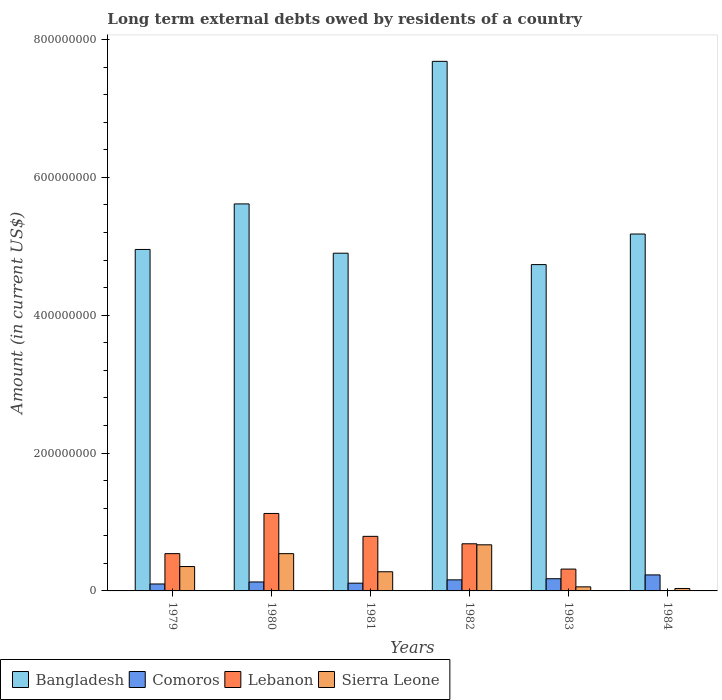How many groups of bars are there?
Offer a very short reply. 6. Are the number of bars per tick equal to the number of legend labels?
Provide a short and direct response. No. Are the number of bars on each tick of the X-axis equal?
Your response must be concise. No. In how many cases, is the number of bars for a given year not equal to the number of legend labels?
Offer a very short reply. 1. What is the amount of long-term external debts owed by residents in Bangladesh in 1980?
Offer a terse response. 5.61e+08. Across all years, what is the maximum amount of long-term external debts owed by residents in Sierra Leone?
Offer a very short reply. 6.69e+07. Across all years, what is the minimum amount of long-term external debts owed by residents in Bangladesh?
Your response must be concise. 4.73e+08. What is the total amount of long-term external debts owed by residents in Lebanon in the graph?
Keep it short and to the point. 3.46e+08. What is the difference between the amount of long-term external debts owed by residents in Lebanon in 1979 and that in 1981?
Your response must be concise. -2.51e+07. What is the difference between the amount of long-term external debts owed by residents in Sierra Leone in 1983 and the amount of long-term external debts owed by residents in Lebanon in 1980?
Provide a short and direct response. -1.06e+08. What is the average amount of long-term external debts owed by residents in Bangladesh per year?
Your answer should be compact. 5.51e+08. In the year 1983, what is the difference between the amount of long-term external debts owed by residents in Sierra Leone and amount of long-term external debts owed by residents in Comoros?
Provide a succinct answer. -1.18e+07. In how many years, is the amount of long-term external debts owed by residents in Comoros greater than 360000000 US$?
Offer a terse response. 0. What is the ratio of the amount of long-term external debts owed by residents in Comoros in 1979 to that in 1983?
Your answer should be very brief. 0.57. Is the amount of long-term external debts owed by residents in Sierra Leone in 1981 less than that in 1983?
Give a very brief answer. No. Is the difference between the amount of long-term external debts owed by residents in Sierra Leone in 1979 and 1984 greater than the difference between the amount of long-term external debts owed by residents in Comoros in 1979 and 1984?
Offer a very short reply. Yes. What is the difference between the highest and the second highest amount of long-term external debts owed by residents in Sierra Leone?
Your answer should be very brief. 1.28e+07. What is the difference between the highest and the lowest amount of long-term external debts owed by residents in Sierra Leone?
Provide a short and direct response. 6.33e+07. Is the sum of the amount of long-term external debts owed by residents in Comoros in 1979 and 1983 greater than the maximum amount of long-term external debts owed by residents in Sierra Leone across all years?
Provide a short and direct response. No. Is it the case that in every year, the sum of the amount of long-term external debts owed by residents in Bangladesh and amount of long-term external debts owed by residents in Sierra Leone is greater than the amount of long-term external debts owed by residents in Comoros?
Offer a terse response. Yes. Are all the bars in the graph horizontal?
Ensure brevity in your answer.  No. What is the difference between two consecutive major ticks on the Y-axis?
Provide a succinct answer. 2.00e+08. Does the graph contain any zero values?
Your answer should be compact. Yes. How many legend labels are there?
Make the answer very short. 4. How are the legend labels stacked?
Ensure brevity in your answer.  Horizontal. What is the title of the graph?
Keep it short and to the point. Long term external debts owed by residents of a country. What is the label or title of the Y-axis?
Make the answer very short. Amount (in current US$). What is the Amount (in current US$) in Bangladesh in 1979?
Your answer should be compact. 4.95e+08. What is the Amount (in current US$) of Comoros in 1979?
Provide a short and direct response. 1.01e+07. What is the Amount (in current US$) in Lebanon in 1979?
Your response must be concise. 5.41e+07. What is the Amount (in current US$) in Sierra Leone in 1979?
Offer a terse response. 3.54e+07. What is the Amount (in current US$) in Bangladesh in 1980?
Keep it short and to the point. 5.61e+08. What is the Amount (in current US$) of Comoros in 1980?
Your answer should be compact. 1.30e+07. What is the Amount (in current US$) in Lebanon in 1980?
Offer a terse response. 1.12e+08. What is the Amount (in current US$) of Sierra Leone in 1980?
Your response must be concise. 5.41e+07. What is the Amount (in current US$) of Bangladesh in 1981?
Keep it short and to the point. 4.90e+08. What is the Amount (in current US$) in Comoros in 1981?
Your answer should be compact. 1.13e+07. What is the Amount (in current US$) of Lebanon in 1981?
Your answer should be very brief. 7.92e+07. What is the Amount (in current US$) in Sierra Leone in 1981?
Your answer should be very brief. 2.78e+07. What is the Amount (in current US$) in Bangladesh in 1982?
Give a very brief answer. 7.68e+08. What is the Amount (in current US$) of Comoros in 1982?
Provide a short and direct response. 1.61e+07. What is the Amount (in current US$) of Lebanon in 1982?
Provide a succinct answer. 6.84e+07. What is the Amount (in current US$) in Sierra Leone in 1982?
Ensure brevity in your answer.  6.69e+07. What is the Amount (in current US$) in Bangladesh in 1983?
Keep it short and to the point. 4.73e+08. What is the Amount (in current US$) in Comoros in 1983?
Your answer should be very brief. 1.77e+07. What is the Amount (in current US$) in Lebanon in 1983?
Provide a succinct answer. 3.17e+07. What is the Amount (in current US$) of Sierra Leone in 1983?
Your answer should be very brief. 5.91e+06. What is the Amount (in current US$) in Bangladesh in 1984?
Keep it short and to the point. 5.18e+08. What is the Amount (in current US$) in Comoros in 1984?
Keep it short and to the point. 2.32e+07. What is the Amount (in current US$) in Lebanon in 1984?
Make the answer very short. 0. What is the Amount (in current US$) in Sierra Leone in 1984?
Your response must be concise. 3.56e+06. Across all years, what is the maximum Amount (in current US$) in Bangladesh?
Provide a short and direct response. 7.68e+08. Across all years, what is the maximum Amount (in current US$) in Comoros?
Give a very brief answer. 2.32e+07. Across all years, what is the maximum Amount (in current US$) in Lebanon?
Provide a short and direct response. 1.12e+08. Across all years, what is the maximum Amount (in current US$) of Sierra Leone?
Give a very brief answer. 6.69e+07. Across all years, what is the minimum Amount (in current US$) of Bangladesh?
Ensure brevity in your answer.  4.73e+08. Across all years, what is the minimum Amount (in current US$) of Comoros?
Keep it short and to the point. 1.01e+07. Across all years, what is the minimum Amount (in current US$) of Sierra Leone?
Offer a terse response. 3.56e+06. What is the total Amount (in current US$) in Bangladesh in the graph?
Your answer should be very brief. 3.31e+09. What is the total Amount (in current US$) in Comoros in the graph?
Your response must be concise. 9.13e+07. What is the total Amount (in current US$) in Lebanon in the graph?
Ensure brevity in your answer.  3.46e+08. What is the total Amount (in current US$) of Sierra Leone in the graph?
Your response must be concise. 1.94e+08. What is the difference between the Amount (in current US$) in Bangladesh in 1979 and that in 1980?
Ensure brevity in your answer.  -6.61e+07. What is the difference between the Amount (in current US$) of Comoros in 1979 and that in 1980?
Your answer should be very brief. -2.92e+06. What is the difference between the Amount (in current US$) of Lebanon in 1979 and that in 1980?
Your response must be concise. -5.83e+07. What is the difference between the Amount (in current US$) in Sierra Leone in 1979 and that in 1980?
Ensure brevity in your answer.  -1.87e+07. What is the difference between the Amount (in current US$) in Bangladesh in 1979 and that in 1981?
Offer a very short reply. 5.44e+06. What is the difference between the Amount (in current US$) of Comoros in 1979 and that in 1981?
Provide a short and direct response. -1.18e+06. What is the difference between the Amount (in current US$) of Lebanon in 1979 and that in 1981?
Your response must be concise. -2.51e+07. What is the difference between the Amount (in current US$) in Sierra Leone in 1979 and that in 1981?
Offer a terse response. 7.58e+06. What is the difference between the Amount (in current US$) of Bangladesh in 1979 and that in 1982?
Provide a short and direct response. -2.73e+08. What is the difference between the Amount (in current US$) of Comoros in 1979 and that in 1982?
Ensure brevity in your answer.  -5.98e+06. What is the difference between the Amount (in current US$) in Lebanon in 1979 and that in 1982?
Provide a succinct answer. -1.43e+07. What is the difference between the Amount (in current US$) in Sierra Leone in 1979 and that in 1982?
Give a very brief answer. -3.15e+07. What is the difference between the Amount (in current US$) in Bangladesh in 1979 and that in 1983?
Keep it short and to the point. 2.20e+07. What is the difference between the Amount (in current US$) of Comoros in 1979 and that in 1983?
Your response must be concise. -7.62e+06. What is the difference between the Amount (in current US$) of Lebanon in 1979 and that in 1983?
Make the answer very short. 2.24e+07. What is the difference between the Amount (in current US$) in Sierra Leone in 1979 and that in 1983?
Your answer should be very brief. 2.95e+07. What is the difference between the Amount (in current US$) of Bangladesh in 1979 and that in 1984?
Keep it short and to the point. -2.24e+07. What is the difference between the Amount (in current US$) of Comoros in 1979 and that in 1984?
Provide a short and direct response. -1.31e+07. What is the difference between the Amount (in current US$) in Sierra Leone in 1979 and that in 1984?
Your answer should be very brief. 3.18e+07. What is the difference between the Amount (in current US$) in Bangladesh in 1980 and that in 1981?
Keep it short and to the point. 7.15e+07. What is the difference between the Amount (in current US$) of Comoros in 1980 and that in 1981?
Provide a succinct answer. 1.74e+06. What is the difference between the Amount (in current US$) in Lebanon in 1980 and that in 1981?
Provide a succinct answer. 3.32e+07. What is the difference between the Amount (in current US$) in Sierra Leone in 1980 and that in 1981?
Provide a succinct answer. 2.63e+07. What is the difference between the Amount (in current US$) of Bangladesh in 1980 and that in 1982?
Give a very brief answer. -2.07e+08. What is the difference between the Amount (in current US$) in Comoros in 1980 and that in 1982?
Make the answer very short. -3.06e+06. What is the difference between the Amount (in current US$) of Lebanon in 1980 and that in 1982?
Provide a short and direct response. 4.40e+07. What is the difference between the Amount (in current US$) in Sierra Leone in 1980 and that in 1982?
Provide a succinct answer. -1.28e+07. What is the difference between the Amount (in current US$) of Bangladesh in 1980 and that in 1983?
Provide a short and direct response. 8.80e+07. What is the difference between the Amount (in current US$) in Comoros in 1980 and that in 1983?
Ensure brevity in your answer.  -4.70e+06. What is the difference between the Amount (in current US$) of Lebanon in 1980 and that in 1983?
Your answer should be compact. 8.07e+07. What is the difference between the Amount (in current US$) of Sierra Leone in 1980 and that in 1983?
Ensure brevity in your answer.  4.82e+07. What is the difference between the Amount (in current US$) of Bangladesh in 1980 and that in 1984?
Give a very brief answer. 4.37e+07. What is the difference between the Amount (in current US$) of Comoros in 1980 and that in 1984?
Your answer should be very brief. -1.02e+07. What is the difference between the Amount (in current US$) of Sierra Leone in 1980 and that in 1984?
Your answer should be very brief. 5.05e+07. What is the difference between the Amount (in current US$) of Bangladesh in 1981 and that in 1982?
Offer a very short reply. -2.78e+08. What is the difference between the Amount (in current US$) in Comoros in 1981 and that in 1982?
Keep it short and to the point. -4.79e+06. What is the difference between the Amount (in current US$) of Lebanon in 1981 and that in 1982?
Make the answer very short. 1.08e+07. What is the difference between the Amount (in current US$) in Sierra Leone in 1981 and that in 1982?
Provide a succinct answer. -3.91e+07. What is the difference between the Amount (in current US$) in Bangladesh in 1981 and that in 1983?
Offer a terse response. 1.65e+07. What is the difference between the Amount (in current US$) of Comoros in 1981 and that in 1983?
Offer a very short reply. -6.43e+06. What is the difference between the Amount (in current US$) of Lebanon in 1981 and that in 1983?
Offer a very short reply. 4.75e+07. What is the difference between the Amount (in current US$) in Sierra Leone in 1981 and that in 1983?
Keep it short and to the point. 2.19e+07. What is the difference between the Amount (in current US$) in Bangladesh in 1981 and that in 1984?
Your answer should be very brief. -2.78e+07. What is the difference between the Amount (in current US$) in Comoros in 1981 and that in 1984?
Offer a very short reply. -1.20e+07. What is the difference between the Amount (in current US$) of Sierra Leone in 1981 and that in 1984?
Provide a short and direct response. 2.42e+07. What is the difference between the Amount (in current US$) of Bangladesh in 1982 and that in 1983?
Your response must be concise. 2.95e+08. What is the difference between the Amount (in current US$) of Comoros in 1982 and that in 1983?
Your answer should be very brief. -1.64e+06. What is the difference between the Amount (in current US$) of Lebanon in 1982 and that in 1983?
Make the answer very short. 3.67e+07. What is the difference between the Amount (in current US$) of Sierra Leone in 1982 and that in 1983?
Offer a very short reply. 6.10e+07. What is the difference between the Amount (in current US$) of Bangladesh in 1982 and that in 1984?
Provide a short and direct response. 2.50e+08. What is the difference between the Amount (in current US$) in Comoros in 1982 and that in 1984?
Provide a short and direct response. -7.17e+06. What is the difference between the Amount (in current US$) in Sierra Leone in 1982 and that in 1984?
Give a very brief answer. 6.33e+07. What is the difference between the Amount (in current US$) of Bangladesh in 1983 and that in 1984?
Your answer should be very brief. -4.43e+07. What is the difference between the Amount (in current US$) of Comoros in 1983 and that in 1984?
Provide a short and direct response. -5.53e+06. What is the difference between the Amount (in current US$) of Sierra Leone in 1983 and that in 1984?
Offer a very short reply. 2.35e+06. What is the difference between the Amount (in current US$) of Bangladesh in 1979 and the Amount (in current US$) of Comoros in 1980?
Provide a succinct answer. 4.82e+08. What is the difference between the Amount (in current US$) of Bangladesh in 1979 and the Amount (in current US$) of Lebanon in 1980?
Offer a terse response. 3.83e+08. What is the difference between the Amount (in current US$) of Bangladesh in 1979 and the Amount (in current US$) of Sierra Leone in 1980?
Make the answer very short. 4.41e+08. What is the difference between the Amount (in current US$) in Comoros in 1979 and the Amount (in current US$) in Lebanon in 1980?
Give a very brief answer. -1.02e+08. What is the difference between the Amount (in current US$) in Comoros in 1979 and the Amount (in current US$) in Sierra Leone in 1980?
Provide a succinct answer. -4.40e+07. What is the difference between the Amount (in current US$) in Lebanon in 1979 and the Amount (in current US$) in Sierra Leone in 1980?
Ensure brevity in your answer.  2.30e+04. What is the difference between the Amount (in current US$) of Bangladesh in 1979 and the Amount (in current US$) of Comoros in 1981?
Ensure brevity in your answer.  4.84e+08. What is the difference between the Amount (in current US$) of Bangladesh in 1979 and the Amount (in current US$) of Lebanon in 1981?
Offer a very short reply. 4.16e+08. What is the difference between the Amount (in current US$) in Bangladesh in 1979 and the Amount (in current US$) in Sierra Leone in 1981?
Give a very brief answer. 4.68e+08. What is the difference between the Amount (in current US$) in Comoros in 1979 and the Amount (in current US$) in Lebanon in 1981?
Your answer should be very brief. -6.91e+07. What is the difference between the Amount (in current US$) of Comoros in 1979 and the Amount (in current US$) of Sierra Leone in 1981?
Ensure brevity in your answer.  -1.77e+07. What is the difference between the Amount (in current US$) in Lebanon in 1979 and the Amount (in current US$) in Sierra Leone in 1981?
Ensure brevity in your answer.  2.63e+07. What is the difference between the Amount (in current US$) of Bangladesh in 1979 and the Amount (in current US$) of Comoros in 1982?
Ensure brevity in your answer.  4.79e+08. What is the difference between the Amount (in current US$) in Bangladesh in 1979 and the Amount (in current US$) in Lebanon in 1982?
Make the answer very short. 4.27e+08. What is the difference between the Amount (in current US$) of Bangladesh in 1979 and the Amount (in current US$) of Sierra Leone in 1982?
Offer a very short reply. 4.28e+08. What is the difference between the Amount (in current US$) in Comoros in 1979 and the Amount (in current US$) in Lebanon in 1982?
Provide a short and direct response. -5.83e+07. What is the difference between the Amount (in current US$) in Comoros in 1979 and the Amount (in current US$) in Sierra Leone in 1982?
Your answer should be very brief. -5.68e+07. What is the difference between the Amount (in current US$) of Lebanon in 1979 and the Amount (in current US$) of Sierra Leone in 1982?
Provide a short and direct response. -1.28e+07. What is the difference between the Amount (in current US$) of Bangladesh in 1979 and the Amount (in current US$) of Comoros in 1983?
Your answer should be compact. 4.78e+08. What is the difference between the Amount (in current US$) of Bangladesh in 1979 and the Amount (in current US$) of Lebanon in 1983?
Offer a terse response. 4.64e+08. What is the difference between the Amount (in current US$) of Bangladesh in 1979 and the Amount (in current US$) of Sierra Leone in 1983?
Offer a very short reply. 4.89e+08. What is the difference between the Amount (in current US$) in Comoros in 1979 and the Amount (in current US$) in Lebanon in 1983?
Offer a very short reply. -2.16e+07. What is the difference between the Amount (in current US$) of Comoros in 1979 and the Amount (in current US$) of Sierra Leone in 1983?
Offer a terse response. 4.17e+06. What is the difference between the Amount (in current US$) of Lebanon in 1979 and the Amount (in current US$) of Sierra Leone in 1983?
Offer a very short reply. 4.82e+07. What is the difference between the Amount (in current US$) in Bangladesh in 1979 and the Amount (in current US$) in Comoros in 1984?
Your response must be concise. 4.72e+08. What is the difference between the Amount (in current US$) of Bangladesh in 1979 and the Amount (in current US$) of Sierra Leone in 1984?
Provide a succinct answer. 4.92e+08. What is the difference between the Amount (in current US$) in Comoros in 1979 and the Amount (in current US$) in Sierra Leone in 1984?
Keep it short and to the point. 6.52e+06. What is the difference between the Amount (in current US$) of Lebanon in 1979 and the Amount (in current US$) of Sierra Leone in 1984?
Your answer should be very brief. 5.05e+07. What is the difference between the Amount (in current US$) of Bangladesh in 1980 and the Amount (in current US$) of Comoros in 1981?
Provide a succinct answer. 5.50e+08. What is the difference between the Amount (in current US$) of Bangladesh in 1980 and the Amount (in current US$) of Lebanon in 1981?
Give a very brief answer. 4.82e+08. What is the difference between the Amount (in current US$) in Bangladesh in 1980 and the Amount (in current US$) in Sierra Leone in 1981?
Provide a short and direct response. 5.34e+08. What is the difference between the Amount (in current US$) in Comoros in 1980 and the Amount (in current US$) in Lebanon in 1981?
Offer a very short reply. -6.62e+07. What is the difference between the Amount (in current US$) in Comoros in 1980 and the Amount (in current US$) in Sierra Leone in 1981?
Make the answer very short. -1.48e+07. What is the difference between the Amount (in current US$) of Lebanon in 1980 and the Amount (in current US$) of Sierra Leone in 1981?
Keep it short and to the point. 8.46e+07. What is the difference between the Amount (in current US$) of Bangladesh in 1980 and the Amount (in current US$) of Comoros in 1982?
Provide a succinct answer. 5.45e+08. What is the difference between the Amount (in current US$) in Bangladesh in 1980 and the Amount (in current US$) in Lebanon in 1982?
Your answer should be compact. 4.93e+08. What is the difference between the Amount (in current US$) of Bangladesh in 1980 and the Amount (in current US$) of Sierra Leone in 1982?
Your answer should be very brief. 4.95e+08. What is the difference between the Amount (in current US$) of Comoros in 1980 and the Amount (in current US$) of Lebanon in 1982?
Your response must be concise. -5.54e+07. What is the difference between the Amount (in current US$) of Comoros in 1980 and the Amount (in current US$) of Sierra Leone in 1982?
Your answer should be very brief. -5.39e+07. What is the difference between the Amount (in current US$) of Lebanon in 1980 and the Amount (in current US$) of Sierra Leone in 1982?
Provide a short and direct response. 4.55e+07. What is the difference between the Amount (in current US$) of Bangladesh in 1980 and the Amount (in current US$) of Comoros in 1983?
Your response must be concise. 5.44e+08. What is the difference between the Amount (in current US$) of Bangladesh in 1980 and the Amount (in current US$) of Lebanon in 1983?
Your answer should be compact. 5.30e+08. What is the difference between the Amount (in current US$) of Bangladesh in 1980 and the Amount (in current US$) of Sierra Leone in 1983?
Your answer should be compact. 5.56e+08. What is the difference between the Amount (in current US$) in Comoros in 1980 and the Amount (in current US$) in Lebanon in 1983?
Offer a terse response. -1.87e+07. What is the difference between the Amount (in current US$) in Comoros in 1980 and the Amount (in current US$) in Sierra Leone in 1983?
Provide a succinct answer. 7.09e+06. What is the difference between the Amount (in current US$) in Lebanon in 1980 and the Amount (in current US$) in Sierra Leone in 1983?
Your answer should be very brief. 1.06e+08. What is the difference between the Amount (in current US$) of Bangladesh in 1980 and the Amount (in current US$) of Comoros in 1984?
Keep it short and to the point. 5.38e+08. What is the difference between the Amount (in current US$) of Bangladesh in 1980 and the Amount (in current US$) of Sierra Leone in 1984?
Your response must be concise. 5.58e+08. What is the difference between the Amount (in current US$) in Comoros in 1980 and the Amount (in current US$) in Sierra Leone in 1984?
Ensure brevity in your answer.  9.44e+06. What is the difference between the Amount (in current US$) of Lebanon in 1980 and the Amount (in current US$) of Sierra Leone in 1984?
Your answer should be very brief. 1.09e+08. What is the difference between the Amount (in current US$) in Bangladesh in 1981 and the Amount (in current US$) in Comoros in 1982?
Keep it short and to the point. 4.74e+08. What is the difference between the Amount (in current US$) of Bangladesh in 1981 and the Amount (in current US$) of Lebanon in 1982?
Ensure brevity in your answer.  4.22e+08. What is the difference between the Amount (in current US$) of Bangladesh in 1981 and the Amount (in current US$) of Sierra Leone in 1982?
Your answer should be compact. 4.23e+08. What is the difference between the Amount (in current US$) in Comoros in 1981 and the Amount (in current US$) in Lebanon in 1982?
Provide a succinct answer. -5.71e+07. What is the difference between the Amount (in current US$) of Comoros in 1981 and the Amount (in current US$) of Sierra Leone in 1982?
Your response must be concise. -5.56e+07. What is the difference between the Amount (in current US$) of Lebanon in 1981 and the Amount (in current US$) of Sierra Leone in 1982?
Your answer should be very brief. 1.23e+07. What is the difference between the Amount (in current US$) of Bangladesh in 1981 and the Amount (in current US$) of Comoros in 1983?
Your answer should be compact. 4.72e+08. What is the difference between the Amount (in current US$) in Bangladesh in 1981 and the Amount (in current US$) in Lebanon in 1983?
Your answer should be compact. 4.58e+08. What is the difference between the Amount (in current US$) of Bangladesh in 1981 and the Amount (in current US$) of Sierra Leone in 1983?
Make the answer very short. 4.84e+08. What is the difference between the Amount (in current US$) of Comoros in 1981 and the Amount (in current US$) of Lebanon in 1983?
Provide a short and direct response. -2.04e+07. What is the difference between the Amount (in current US$) in Comoros in 1981 and the Amount (in current US$) in Sierra Leone in 1983?
Give a very brief answer. 5.35e+06. What is the difference between the Amount (in current US$) in Lebanon in 1981 and the Amount (in current US$) in Sierra Leone in 1983?
Your answer should be very brief. 7.33e+07. What is the difference between the Amount (in current US$) in Bangladesh in 1981 and the Amount (in current US$) in Comoros in 1984?
Provide a short and direct response. 4.67e+08. What is the difference between the Amount (in current US$) of Bangladesh in 1981 and the Amount (in current US$) of Sierra Leone in 1984?
Your answer should be very brief. 4.86e+08. What is the difference between the Amount (in current US$) in Comoros in 1981 and the Amount (in current US$) in Sierra Leone in 1984?
Ensure brevity in your answer.  7.70e+06. What is the difference between the Amount (in current US$) of Lebanon in 1981 and the Amount (in current US$) of Sierra Leone in 1984?
Your answer should be compact. 7.56e+07. What is the difference between the Amount (in current US$) in Bangladesh in 1982 and the Amount (in current US$) in Comoros in 1983?
Offer a terse response. 7.51e+08. What is the difference between the Amount (in current US$) of Bangladesh in 1982 and the Amount (in current US$) of Lebanon in 1983?
Provide a short and direct response. 7.37e+08. What is the difference between the Amount (in current US$) of Bangladesh in 1982 and the Amount (in current US$) of Sierra Leone in 1983?
Your answer should be very brief. 7.62e+08. What is the difference between the Amount (in current US$) of Comoros in 1982 and the Amount (in current US$) of Lebanon in 1983?
Provide a succinct answer. -1.56e+07. What is the difference between the Amount (in current US$) in Comoros in 1982 and the Amount (in current US$) in Sierra Leone in 1983?
Your response must be concise. 1.01e+07. What is the difference between the Amount (in current US$) of Lebanon in 1982 and the Amount (in current US$) of Sierra Leone in 1983?
Keep it short and to the point. 6.25e+07. What is the difference between the Amount (in current US$) of Bangladesh in 1982 and the Amount (in current US$) of Comoros in 1984?
Give a very brief answer. 7.45e+08. What is the difference between the Amount (in current US$) of Bangladesh in 1982 and the Amount (in current US$) of Sierra Leone in 1984?
Your answer should be compact. 7.65e+08. What is the difference between the Amount (in current US$) in Comoros in 1982 and the Amount (in current US$) in Sierra Leone in 1984?
Offer a terse response. 1.25e+07. What is the difference between the Amount (in current US$) in Lebanon in 1982 and the Amount (in current US$) in Sierra Leone in 1984?
Your response must be concise. 6.48e+07. What is the difference between the Amount (in current US$) in Bangladesh in 1983 and the Amount (in current US$) in Comoros in 1984?
Ensure brevity in your answer.  4.50e+08. What is the difference between the Amount (in current US$) of Bangladesh in 1983 and the Amount (in current US$) of Sierra Leone in 1984?
Give a very brief answer. 4.70e+08. What is the difference between the Amount (in current US$) in Comoros in 1983 and the Amount (in current US$) in Sierra Leone in 1984?
Give a very brief answer. 1.41e+07. What is the difference between the Amount (in current US$) of Lebanon in 1983 and the Amount (in current US$) of Sierra Leone in 1984?
Your answer should be compact. 2.81e+07. What is the average Amount (in current US$) of Bangladesh per year?
Offer a very short reply. 5.51e+08. What is the average Amount (in current US$) in Comoros per year?
Give a very brief answer. 1.52e+07. What is the average Amount (in current US$) in Lebanon per year?
Your answer should be compact. 5.76e+07. What is the average Amount (in current US$) of Sierra Leone per year?
Keep it short and to the point. 3.23e+07. In the year 1979, what is the difference between the Amount (in current US$) of Bangladesh and Amount (in current US$) of Comoros?
Make the answer very short. 4.85e+08. In the year 1979, what is the difference between the Amount (in current US$) in Bangladesh and Amount (in current US$) in Lebanon?
Keep it short and to the point. 4.41e+08. In the year 1979, what is the difference between the Amount (in current US$) in Bangladesh and Amount (in current US$) in Sierra Leone?
Your response must be concise. 4.60e+08. In the year 1979, what is the difference between the Amount (in current US$) in Comoros and Amount (in current US$) in Lebanon?
Provide a short and direct response. -4.40e+07. In the year 1979, what is the difference between the Amount (in current US$) of Comoros and Amount (in current US$) of Sierra Leone?
Your answer should be compact. -2.53e+07. In the year 1979, what is the difference between the Amount (in current US$) in Lebanon and Amount (in current US$) in Sierra Leone?
Your answer should be compact. 1.87e+07. In the year 1980, what is the difference between the Amount (in current US$) in Bangladesh and Amount (in current US$) in Comoros?
Your answer should be very brief. 5.48e+08. In the year 1980, what is the difference between the Amount (in current US$) in Bangladesh and Amount (in current US$) in Lebanon?
Ensure brevity in your answer.  4.49e+08. In the year 1980, what is the difference between the Amount (in current US$) in Bangladesh and Amount (in current US$) in Sierra Leone?
Your answer should be compact. 5.07e+08. In the year 1980, what is the difference between the Amount (in current US$) in Comoros and Amount (in current US$) in Lebanon?
Give a very brief answer. -9.94e+07. In the year 1980, what is the difference between the Amount (in current US$) of Comoros and Amount (in current US$) of Sierra Leone?
Provide a succinct answer. -4.11e+07. In the year 1980, what is the difference between the Amount (in current US$) of Lebanon and Amount (in current US$) of Sierra Leone?
Your response must be concise. 5.83e+07. In the year 1981, what is the difference between the Amount (in current US$) of Bangladesh and Amount (in current US$) of Comoros?
Provide a succinct answer. 4.79e+08. In the year 1981, what is the difference between the Amount (in current US$) in Bangladesh and Amount (in current US$) in Lebanon?
Offer a very short reply. 4.11e+08. In the year 1981, what is the difference between the Amount (in current US$) of Bangladesh and Amount (in current US$) of Sierra Leone?
Keep it short and to the point. 4.62e+08. In the year 1981, what is the difference between the Amount (in current US$) in Comoros and Amount (in current US$) in Lebanon?
Offer a very short reply. -6.79e+07. In the year 1981, what is the difference between the Amount (in current US$) in Comoros and Amount (in current US$) in Sierra Leone?
Your answer should be very brief. -1.65e+07. In the year 1981, what is the difference between the Amount (in current US$) in Lebanon and Amount (in current US$) in Sierra Leone?
Your answer should be very brief. 5.14e+07. In the year 1982, what is the difference between the Amount (in current US$) of Bangladesh and Amount (in current US$) of Comoros?
Your response must be concise. 7.52e+08. In the year 1982, what is the difference between the Amount (in current US$) of Bangladesh and Amount (in current US$) of Lebanon?
Make the answer very short. 7.00e+08. In the year 1982, what is the difference between the Amount (in current US$) in Bangladesh and Amount (in current US$) in Sierra Leone?
Provide a succinct answer. 7.01e+08. In the year 1982, what is the difference between the Amount (in current US$) in Comoros and Amount (in current US$) in Lebanon?
Your answer should be very brief. -5.23e+07. In the year 1982, what is the difference between the Amount (in current US$) of Comoros and Amount (in current US$) of Sierra Leone?
Offer a terse response. -5.08e+07. In the year 1982, what is the difference between the Amount (in current US$) in Lebanon and Amount (in current US$) in Sierra Leone?
Your answer should be compact. 1.48e+06. In the year 1983, what is the difference between the Amount (in current US$) of Bangladesh and Amount (in current US$) of Comoros?
Give a very brief answer. 4.56e+08. In the year 1983, what is the difference between the Amount (in current US$) in Bangladesh and Amount (in current US$) in Lebanon?
Ensure brevity in your answer.  4.42e+08. In the year 1983, what is the difference between the Amount (in current US$) of Bangladesh and Amount (in current US$) of Sierra Leone?
Your answer should be compact. 4.67e+08. In the year 1983, what is the difference between the Amount (in current US$) of Comoros and Amount (in current US$) of Lebanon?
Ensure brevity in your answer.  -1.40e+07. In the year 1983, what is the difference between the Amount (in current US$) of Comoros and Amount (in current US$) of Sierra Leone?
Provide a short and direct response. 1.18e+07. In the year 1983, what is the difference between the Amount (in current US$) in Lebanon and Amount (in current US$) in Sierra Leone?
Your answer should be compact. 2.58e+07. In the year 1984, what is the difference between the Amount (in current US$) in Bangladesh and Amount (in current US$) in Comoros?
Ensure brevity in your answer.  4.95e+08. In the year 1984, what is the difference between the Amount (in current US$) in Bangladesh and Amount (in current US$) in Sierra Leone?
Keep it short and to the point. 5.14e+08. In the year 1984, what is the difference between the Amount (in current US$) in Comoros and Amount (in current US$) in Sierra Leone?
Give a very brief answer. 1.97e+07. What is the ratio of the Amount (in current US$) of Bangladesh in 1979 to that in 1980?
Offer a very short reply. 0.88. What is the ratio of the Amount (in current US$) in Comoros in 1979 to that in 1980?
Your answer should be very brief. 0.78. What is the ratio of the Amount (in current US$) in Lebanon in 1979 to that in 1980?
Your answer should be compact. 0.48. What is the ratio of the Amount (in current US$) in Sierra Leone in 1979 to that in 1980?
Your response must be concise. 0.65. What is the ratio of the Amount (in current US$) in Bangladesh in 1979 to that in 1981?
Give a very brief answer. 1.01. What is the ratio of the Amount (in current US$) in Comoros in 1979 to that in 1981?
Ensure brevity in your answer.  0.89. What is the ratio of the Amount (in current US$) of Lebanon in 1979 to that in 1981?
Your answer should be very brief. 0.68. What is the ratio of the Amount (in current US$) in Sierra Leone in 1979 to that in 1981?
Give a very brief answer. 1.27. What is the ratio of the Amount (in current US$) in Bangladesh in 1979 to that in 1982?
Your answer should be very brief. 0.64. What is the ratio of the Amount (in current US$) of Comoros in 1979 to that in 1982?
Provide a short and direct response. 0.63. What is the ratio of the Amount (in current US$) of Lebanon in 1979 to that in 1982?
Give a very brief answer. 0.79. What is the ratio of the Amount (in current US$) in Sierra Leone in 1979 to that in 1982?
Keep it short and to the point. 0.53. What is the ratio of the Amount (in current US$) in Bangladesh in 1979 to that in 1983?
Offer a terse response. 1.05. What is the ratio of the Amount (in current US$) in Comoros in 1979 to that in 1983?
Provide a succinct answer. 0.57. What is the ratio of the Amount (in current US$) in Lebanon in 1979 to that in 1983?
Ensure brevity in your answer.  1.71. What is the ratio of the Amount (in current US$) in Sierra Leone in 1979 to that in 1983?
Ensure brevity in your answer.  5.99. What is the ratio of the Amount (in current US$) in Bangladesh in 1979 to that in 1984?
Your response must be concise. 0.96. What is the ratio of the Amount (in current US$) in Comoros in 1979 to that in 1984?
Provide a short and direct response. 0.43. What is the ratio of the Amount (in current US$) of Sierra Leone in 1979 to that in 1984?
Give a very brief answer. 9.95. What is the ratio of the Amount (in current US$) in Bangladesh in 1980 to that in 1981?
Give a very brief answer. 1.15. What is the ratio of the Amount (in current US$) of Comoros in 1980 to that in 1981?
Your response must be concise. 1.15. What is the ratio of the Amount (in current US$) in Lebanon in 1980 to that in 1981?
Make the answer very short. 1.42. What is the ratio of the Amount (in current US$) of Sierra Leone in 1980 to that in 1981?
Offer a very short reply. 1.95. What is the ratio of the Amount (in current US$) in Bangladesh in 1980 to that in 1982?
Provide a short and direct response. 0.73. What is the ratio of the Amount (in current US$) of Comoros in 1980 to that in 1982?
Offer a very short reply. 0.81. What is the ratio of the Amount (in current US$) in Lebanon in 1980 to that in 1982?
Your answer should be compact. 1.64. What is the ratio of the Amount (in current US$) in Sierra Leone in 1980 to that in 1982?
Provide a succinct answer. 0.81. What is the ratio of the Amount (in current US$) of Bangladesh in 1980 to that in 1983?
Keep it short and to the point. 1.19. What is the ratio of the Amount (in current US$) in Comoros in 1980 to that in 1983?
Provide a short and direct response. 0.73. What is the ratio of the Amount (in current US$) of Lebanon in 1980 to that in 1983?
Ensure brevity in your answer.  3.55. What is the ratio of the Amount (in current US$) of Sierra Leone in 1980 to that in 1983?
Keep it short and to the point. 9.16. What is the ratio of the Amount (in current US$) in Bangladesh in 1980 to that in 1984?
Your response must be concise. 1.08. What is the ratio of the Amount (in current US$) of Comoros in 1980 to that in 1984?
Give a very brief answer. 0.56. What is the ratio of the Amount (in current US$) in Sierra Leone in 1980 to that in 1984?
Give a very brief answer. 15.21. What is the ratio of the Amount (in current US$) of Bangladesh in 1981 to that in 1982?
Ensure brevity in your answer.  0.64. What is the ratio of the Amount (in current US$) of Comoros in 1981 to that in 1982?
Ensure brevity in your answer.  0.7. What is the ratio of the Amount (in current US$) in Lebanon in 1981 to that in 1982?
Ensure brevity in your answer.  1.16. What is the ratio of the Amount (in current US$) in Sierra Leone in 1981 to that in 1982?
Your answer should be compact. 0.42. What is the ratio of the Amount (in current US$) in Bangladesh in 1981 to that in 1983?
Your answer should be compact. 1.03. What is the ratio of the Amount (in current US$) of Comoros in 1981 to that in 1983?
Provide a succinct answer. 0.64. What is the ratio of the Amount (in current US$) of Lebanon in 1981 to that in 1983?
Your answer should be compact. 2.5. What is the ratio of the Amount (in current US$) in Sierra Leone in 1981 to that in 1983?
Your answer should be compact. 4.71. What is the ratio of the Amount (in current US$) of Bangladesh in 1981 to that in 1984?
Offer a terse response. 0.95. What is the ratio of the Amount (in current US$) in Comoros in 1981 to that in 1984?
Give a very brief answer. 0.48. What is the ratio of the Amount (in current US$) in Sierra Leone in 1981 to that in 1984?
Your response must be concise. 7.82. What is the ratio of the Amount (in current US$) in Bangladesh in 1982 to that in 1983?
Offer a very short reply. 1.62. What is the ratio of the Amount (in current US$) in Comoros in 1982 to that in 1983?
Your answer should be compact. 0.91. What is the ratio of the Amount (in current US$) in Lebanon in 1982 to that in 1983?
Offer a terse response. 2.16. What is the ratio of the Amount (in current US$) of Sierra Leone in 1982 to that in 1983?
Offer a very short reply. 11.32. What is the ratio of the Amount (in current US$) in Bangladesh in 1982 to that in 1984?
Offer a very short reply. 1.48. What is the ratio of the Amount (in current US$) in Comoros in 1982 to that in 1984?
Ensure brevity in your answer.  0.69. What is the ratio of the Amount (in current US$) in Sierra Leone in 1982 to that in 1984?
Provide a short and direct response. 18.81. What is the ratio of the Amount (in current US$) of Bangladesh in 1983 to that in 1984?
Your response must be concise. 0.91. What is the ratio of the Amount (in current US$) of Comoros in 1983 to that in 1984?
Offer a terse response. 0.76. What is the ratio of the Amount (in current US$) in Sierra Leone in 1983 to that in 1984?
Your answer should be compact. 1.66. What is the difference between the highest and the second highest Amount (in current US$) of Bangladesh?
Your response must be concise. 2.07e+08. What is the difference between the highest and the second highest Amount (in current US$) of Comoros?
Offer a terse response. 5.53e+06. What is the difference between the highest and the second highest Amount (in current US$) in Lebanon?
Offer a very short reply. 3.32e+07. What is the difference between the highest and the second highest Amount (in current US$) in Sierra Leone?
Offer a terse response. 1.28e+07. What is the difference between the highest and the lowest Amount (in current US$) in Bangladesh?
Give a very brief answer. 2.95e+08. What is the difference between the highest and the lowest Amount (in current US$) of Comoros?
Give a very brief answer. 1.31e+07. What is the difference between the highest and the lowest Amount (in current US$) in Lebanon?
Keep it short and to the point. 1.12e+08. What is the difference between the highest and the lowest Amount (in current US$) in Sierra Leone?
Give a very brief answer. 6.33e+07. 